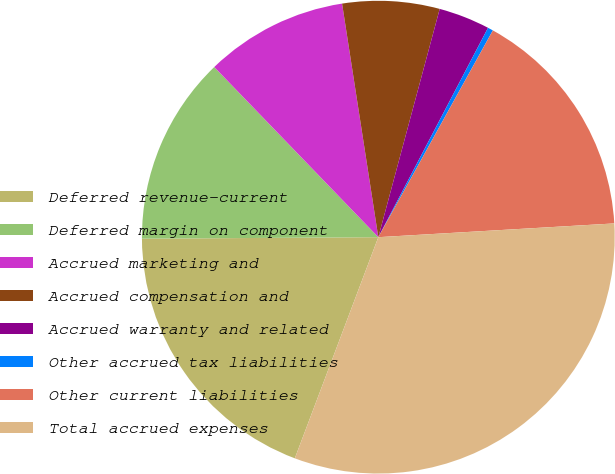<chart> <loc_0><loc_0><loc_500><loc_500><pie_chart><fcel>Deferred revenue-current<fcel>Deferred margin on component<fcel>Accrued marketing and<fcel>Accrued compensation and<fcel>Accrued warranty and related<fcel>Other accrued tax liabilities<fcel>Other current liabilities<fcel>Total accrued expenses<nl><fcel>19.15%<fcel>12.89%<fcel>9.76%<fcel>6.63%<fcel>3.5%<fcel>0.37%<fcel>16.02%<fcel>31.67%<nl></chart> 